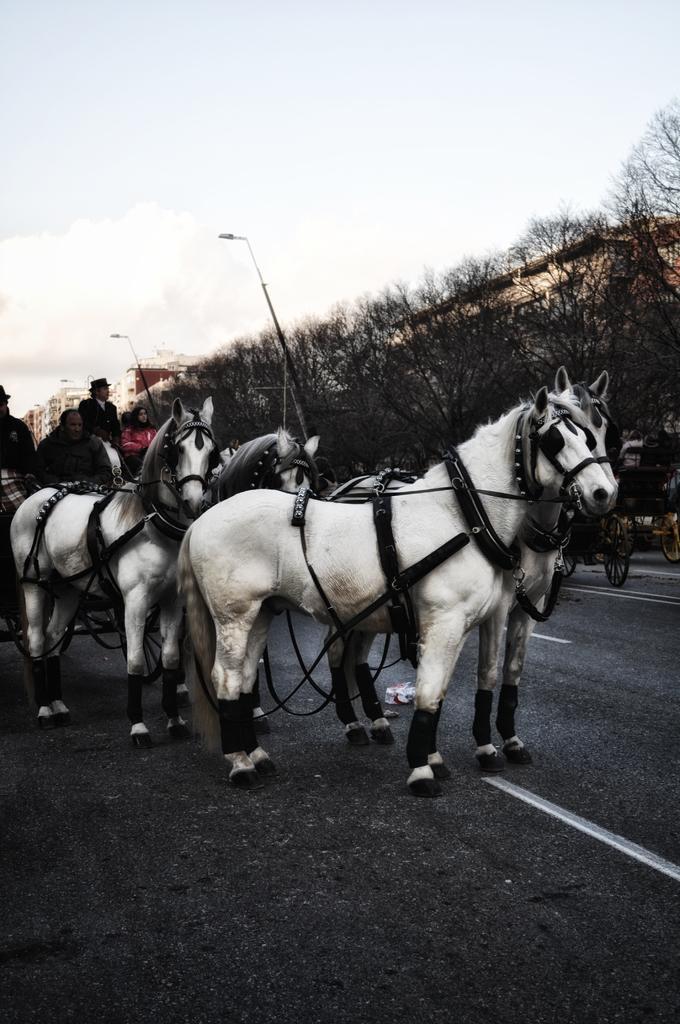In one or two sentences, can you explain what this image depicts? We can see sitting on cart and we can see horses on the road. In the background we can see trees,lights on poles and sky. 